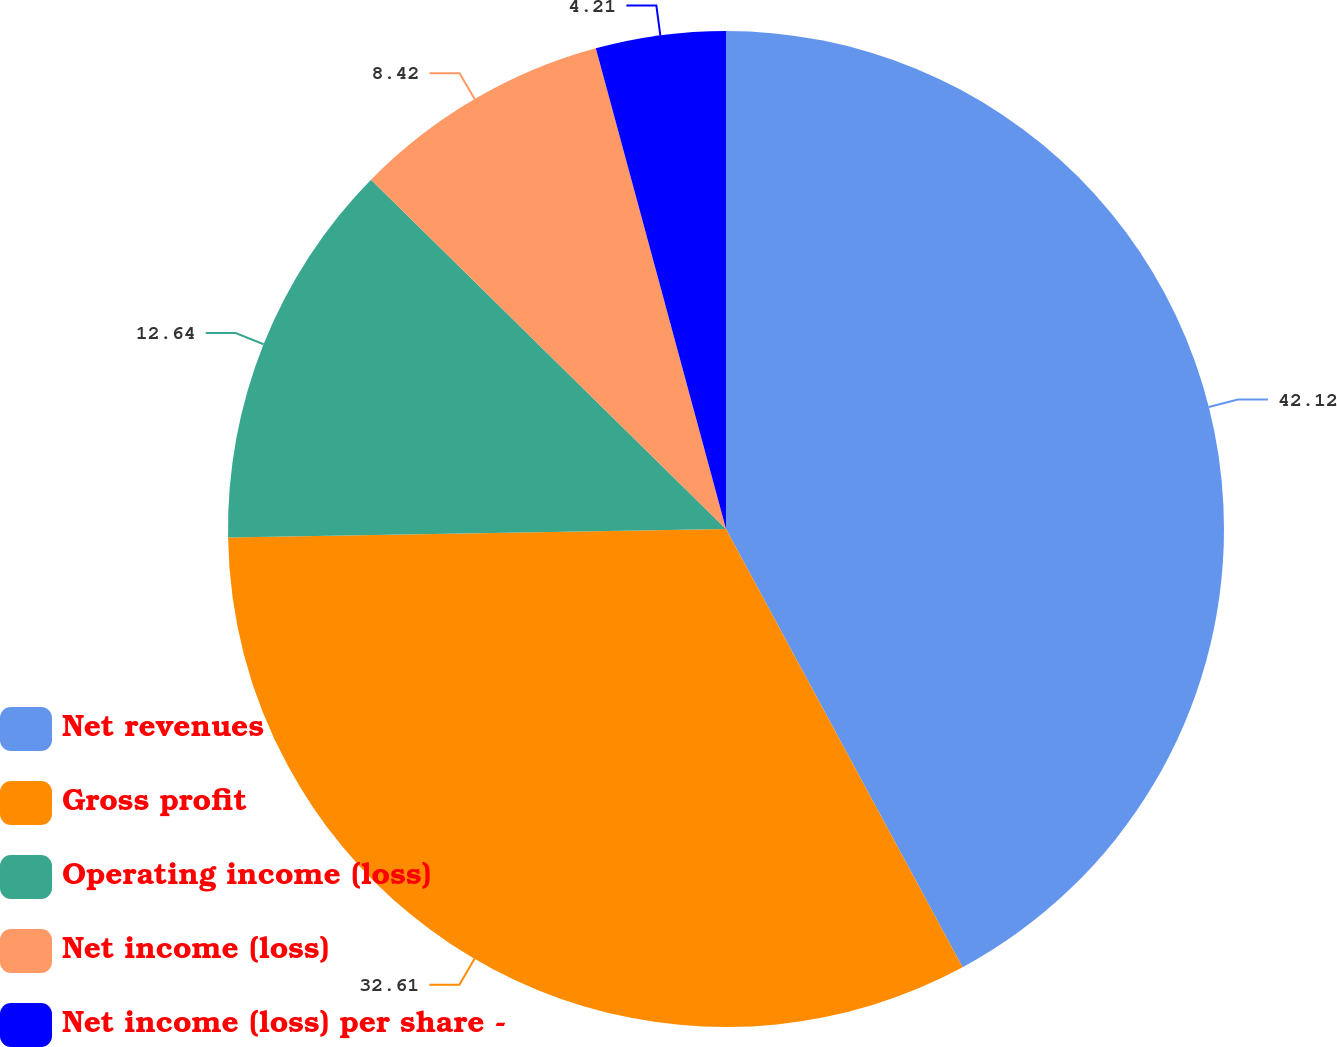<chart> <loc_0><loc_0><loc_500><loc_500><pie_chart><fcel>Net revenues<fcel>Gross profit<fcel>Operating income (loss)<fcel>Net income (loss)<fcel>Net income (loss) per share -<nl><fcel>42.12%<fcel>32.61%<fcel>12.64%<fcel>8.42%<fcel>4.21%<nl></chart> 